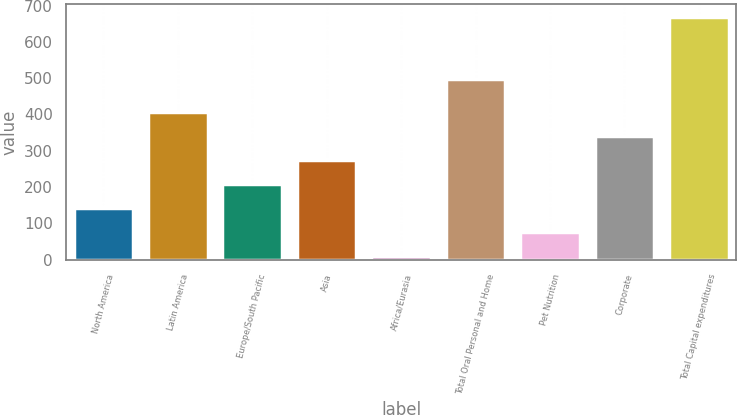Convert chart. <chart><loc_0><loc_0><loc_500><loc_500><bar_chart><fcel>North America<fcel>Latin America<fcel>Europe/South Pacific<fcel>Asia<fcel>Africa/Eurasia<fcel>Total Oral Personal and Home<fcel>Pet Nutrition<fcel>Corporate<fcel>Total Capital expenditures<nl><fcel>142.8<fcel>406.4<fcel>208.7<fcel>274.6<fcel>11<fcel>497<fcel>76.9<fcel>340.5<fcel>670<nl></chart> 